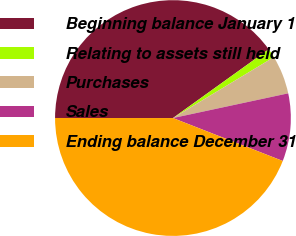Convert chart. <chart><loc_0><loc_0><loc_500><loc_500><pie_chart><fcel>Beginning balance January 1<fcel>Relating to assets still held<fcel>Purchases<fcel>Sales<fcel>Ending balance December 31<nl><fcel>40.08%<fcel>1.27%<fcel>5.28%<fcel>9.29%<fcel>44.08%<nl></chart> 